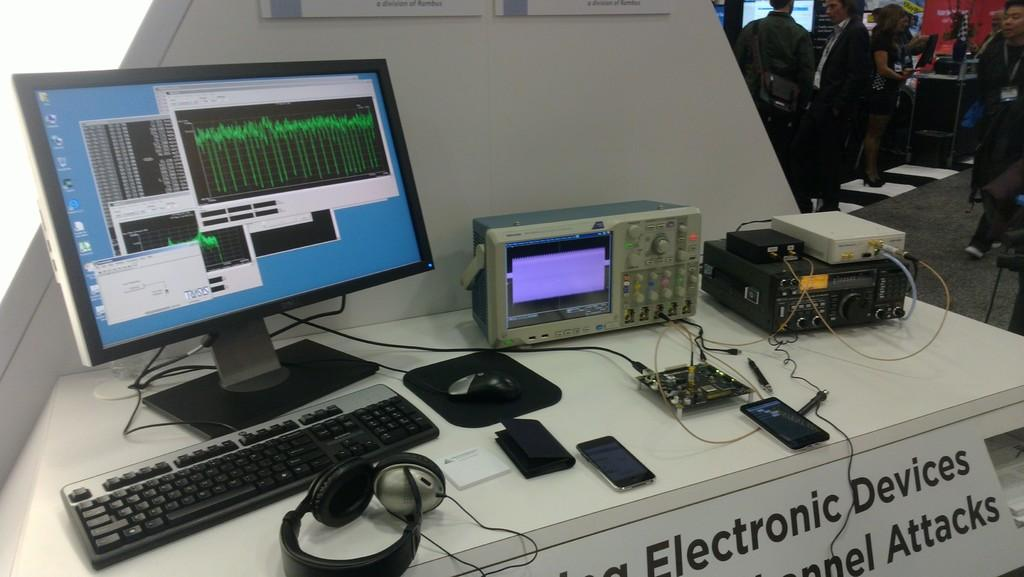<image>
Summarize the visual content of the image. A table with a partial sign reading Electronic Devices has several cellphone, keyboards and monitors on it. 